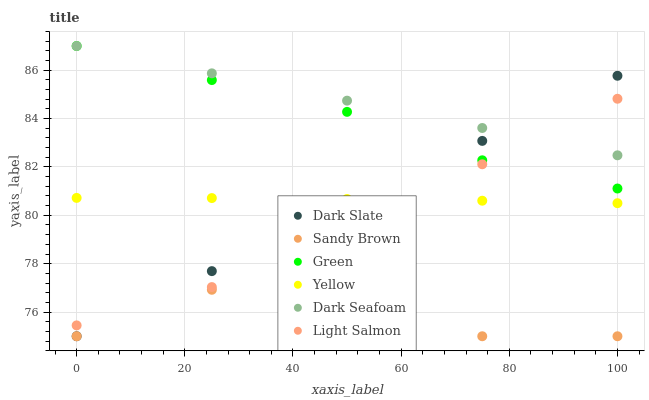Does Sandy Brown have the minimum area under the curve?
Answer yes or no. Yes. Does Dark Seafoam have the maximum area under the curve?
Answer yes or no. Yes. Does Yellow have the minimum area under the curve?
Answer yes or no. No. Does Yellow have the maximum area under the curve?
Answer yes or no. No. Is Dark Slate the smoothest?
Answer yes or no. Yes. Is Sandy Brown the roughest?
Answer yes or no. Yes. Is Yellow the smoothest?
Answer yes or no. No. Is Yellow the roughest?
Answer yes or no. No. Does Dark Slate have the lowest value?
Answer yes or no. Yes. Does Yellow have the lowest value?
Answer yes or no. No. Does Green have the highest value?
Answer yes or no. Yes. Does Yellow have the highest value?
Answer yes or no. No. Is Sandy Brown less than Green?
Answer yes or no. Yes. Is Green greater than Yellow?
Answer yes or no. Yes. Does Dark Slate intersect Green?
Answer yes or no. Yes. Is Dark Slate less than Green?
Answer yes or no. No. Is Dark Slate greater than Green?
Answer yes or no. No. Does Sandy Brown intersect Green?
Answer yes or no. No. 